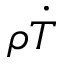<formula> <loc_0><loc_0><loc_500><loc_500>\rho \dot { T }</formula> 